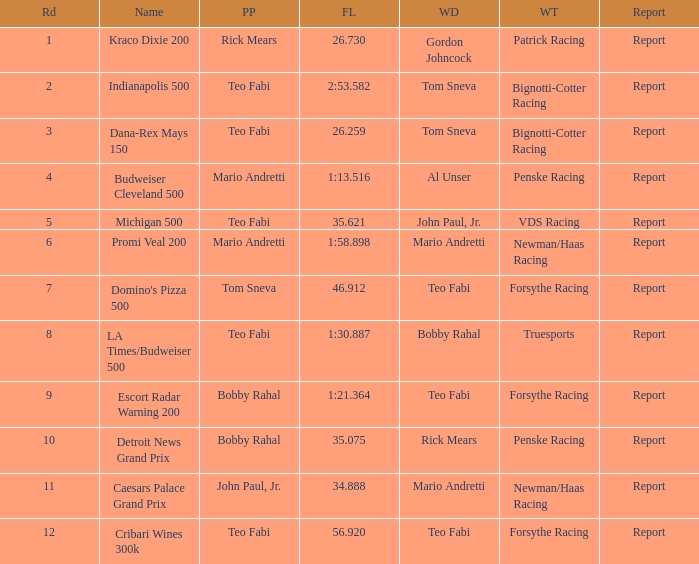How many reports are there in the race that Forsythe Racing won and Teo Fabi had the pole position in? 1.0. 